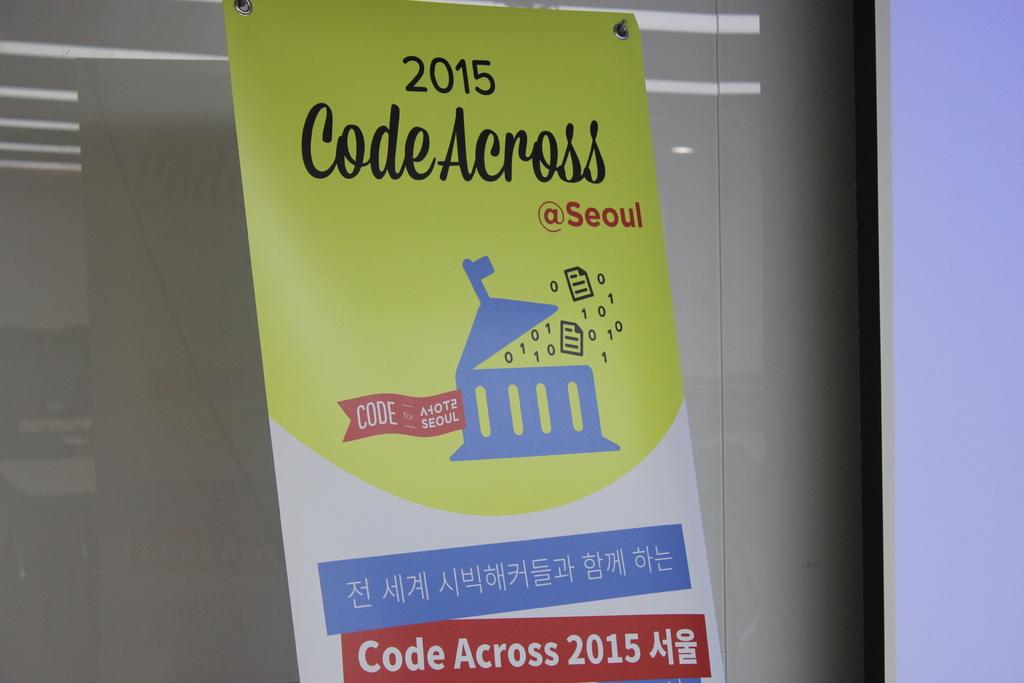<image>
Summarize the visual content of the image. Code across 2015 with chinese language at the bottom 